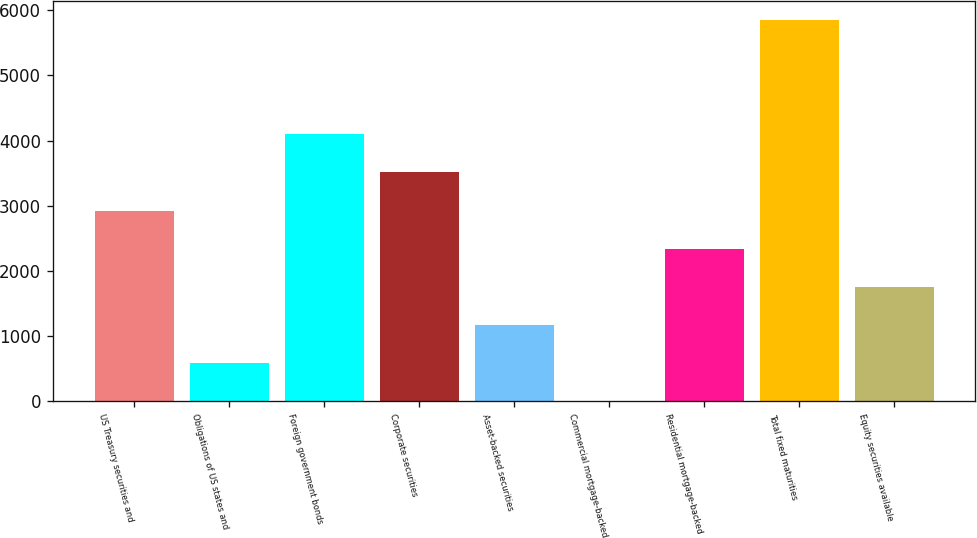Convert chart. <chart><loc_0><loc_0><loc_500><loc_500><bar_chart><fcel>US Treasury securities and<fcel>Obligations of US states and<fcel>Foreign government bonds<fcel>Corporate securities<fcel>Asset-backed securities<fcel>Commercial mortgage-backed<fcel>Residential mortgage-backed<fcel>Total fixed maturities<fcel>Equity securities available<nl><fcel>2926<fcel>589.2<fcel>4094.4<fcel>3510.2<fcel>1173.4<fcel>5<fcel>2341.8<fcel>5847<fcel>1757.6<nl></chart> 